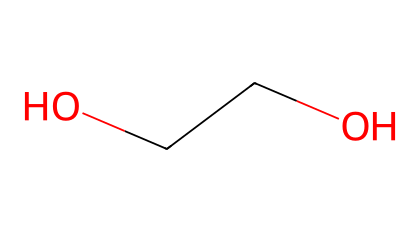How many carbon atoms are in ethylene glycol? The SMILES representation indicates two carbon atoms (C(CO)O), as each "C" in the string represents a carbon atom in the molecular structure.
Answer: 2 What functional groups are present in ethylene glycol? The molecular structure reveals that there are two hydroxyl (-OH) groups, indicating that ethylene glycol has alcohol functional groups.
Answer: hydroxyl groups What is the molecular formula of ethylene glycol? By analyzing the SMILES representation, the molecular formula can be derived as C2H6O2, reflecting 2 carbon atoms, 6 hydrogen atoms, and 2 oxygen atoms.
Answer: C2H6O2 Is ethylene glycol a primary or secondary alcohol? The structure shows that each carbon is bonded to one hydroxyl group, confirming ethylene glycol as a primary alcohol since each -OH group is attached to a terminal carbon.
Answer: primary What is the boiling point of ethylene glycol? Ethylene glycol typically has a boiling point around 197 degrees Celsius, which is a distinct property of this chemical derived from its molecular interactions and structure.
Answer: 197 How many hydrogen atoms are bonded to each carbon in ethylene glycol? Evaluating the structure, each carbon atom is bonded to two hydrogen atoms, totaling four hydrogen atoms when considering the molecule's complete structure.
Answer: 2 What effect does the presence of hydroxyl groups have on ethylene glycol's solubility? The presence of hydroxyl groups enhances solubility in water due to their ability to form hydrogen bonds with water molecules. This is significant when considering its usage as an antifreeze agent.
Answer: increased solubility 